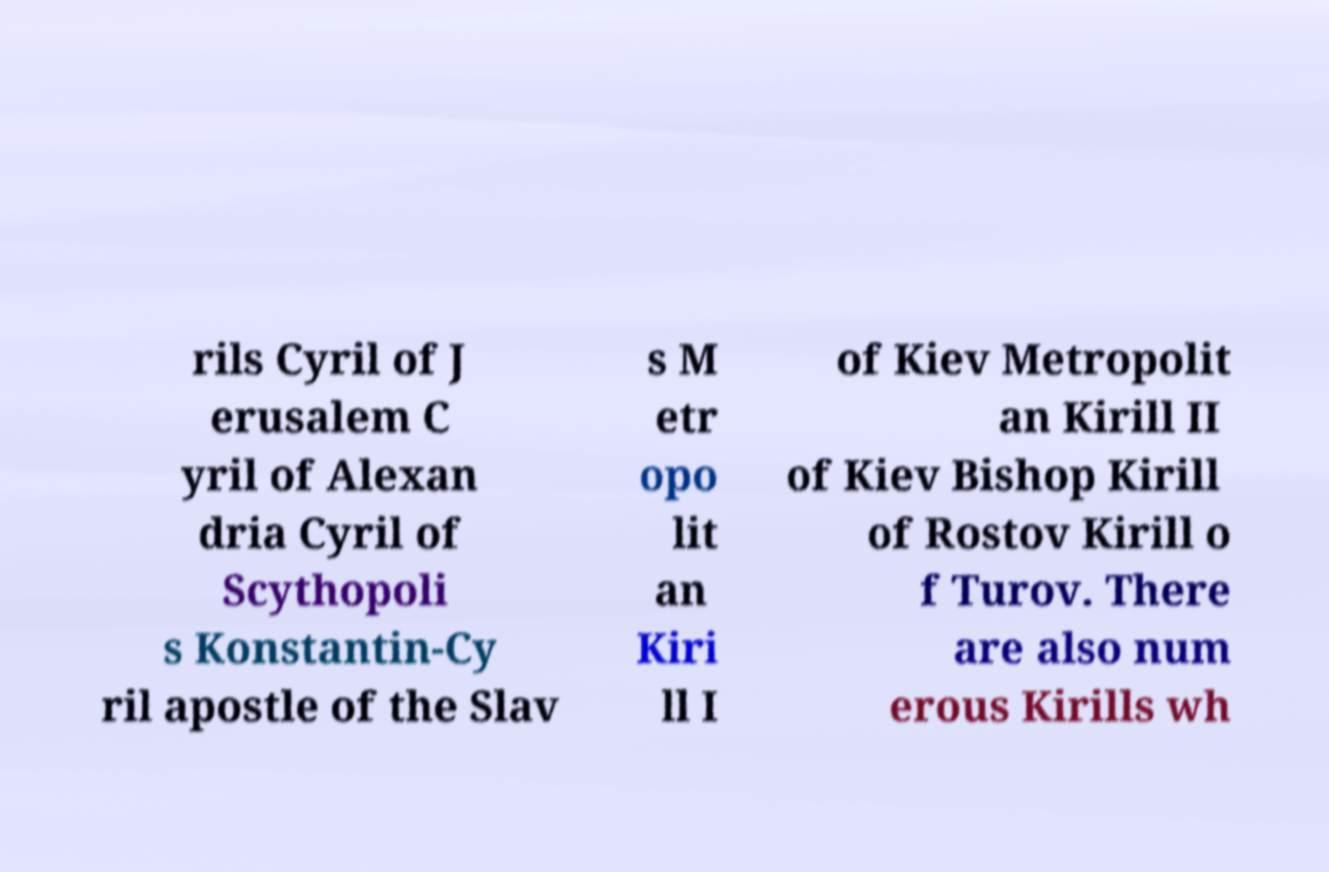Could you assist in decoding the text presented in this image and type it out clearly? rils Cyril of J erusalem C yril of Alexan dria Cyril of Scythopoli s Konstantin-Cy ril apostle of the Slav s M etr opo lit an Kiri ll I of Kiev Metropolit an Kirill II of Kiev Bishop Kirill of Rostov Kirill o f Turov. There are also num erous Kirills wh 